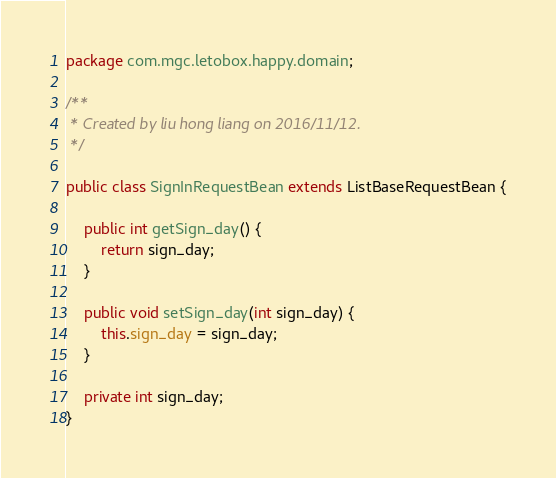Convert code to text. <code><loc_0><loc_0><loc_500><loc_500><_Java_>package com.mgc.letobox.happy.domain;

/**
 * Created by liu hong liang on 2016/11/12.
 */

public class SignInRequestBean extends ListBaseRequestBean {

    public int getSign_day() {
        return sign_day;
    }

    public void setSign_day(int sign_day) {
        this.sign_day = sign_day;
    }

    private int sign_day;
}
</code> 